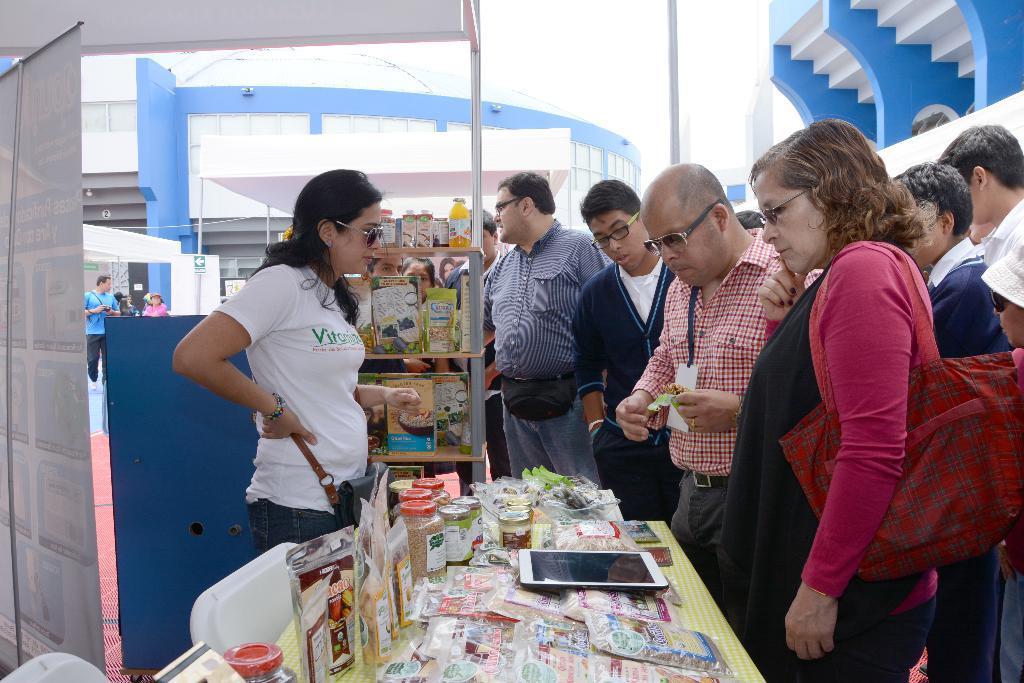Could you give a brief overview of what you see in this image? In this picture there is a table in the center of the image, on which there is a netbook and grocery items and there is a lady and a poster on the left side of the image, there is a rack behind the lady, there are other people in front of the table and there are buildings in the background area of the image. 